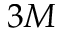Convert formula to latex. <formula><loc_0><loc_0><loc_500><loc_500>3 M</formula> 